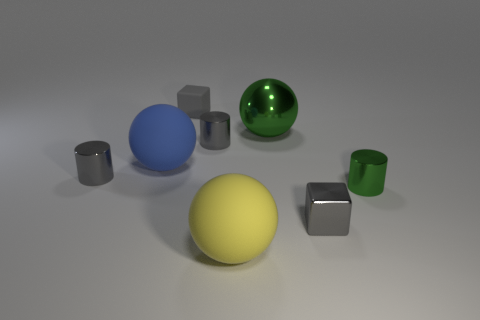Add 2 purple metallic balls. How many objects exist? 10 Subtract all balls. How many objects are left? 5 Subtract all big yellow rubber things. Subtract all small gray cylinders. How many objects are left? 5 Add 1 small rubber blocks. How many small rubber blocks are left? 2 Add 2 gray cylinders. How many gray cylinders exist? 4 Subtract 0 purple cylinders. How many objects are left? 8 